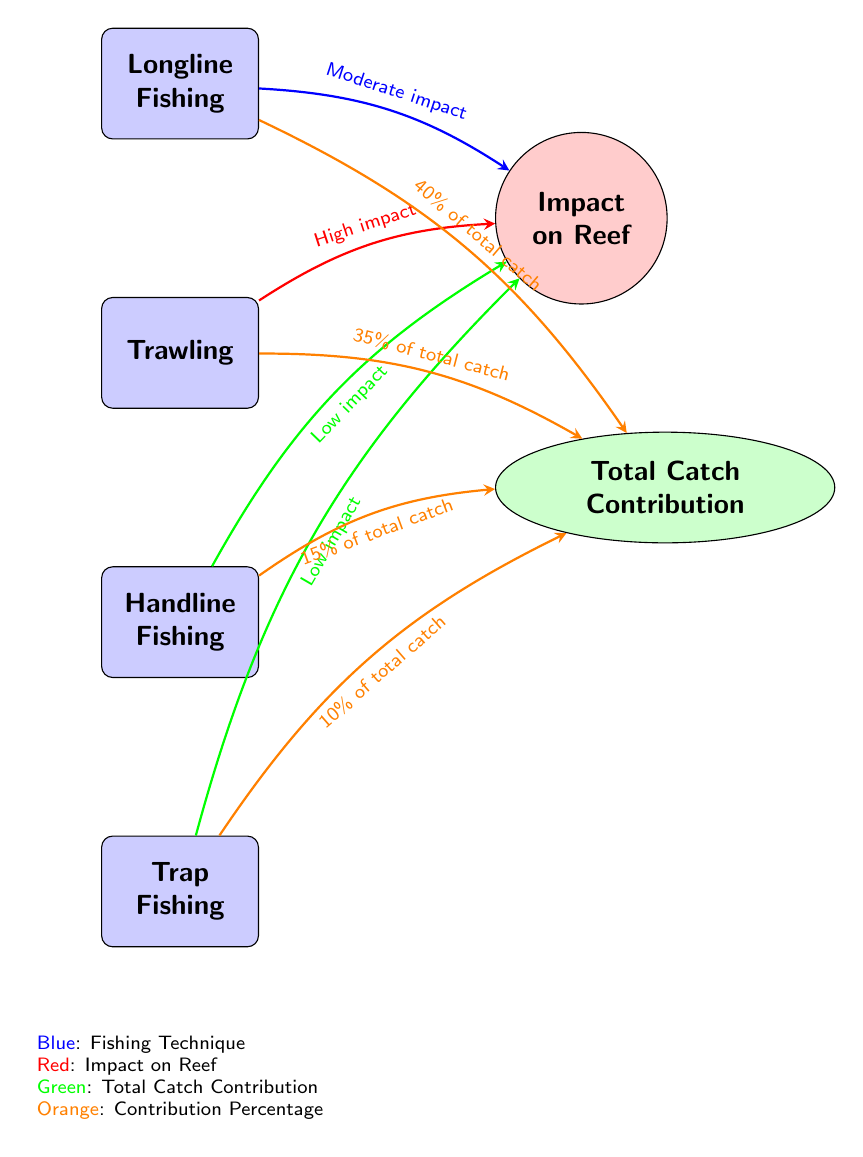What is the total catch contribution percentage for Longline Fishing? From the diagram, it's indicated that Longline Fishing contributes 40% of total catch, which is clearly labeled on the arrow pointing to the "Total Catch Contribution" node.
Answer: 40% What is the impact of Trawling on the reef? The diagram specifies that Trawling has a high impact on the reef, which is represented by the red arrow leading from the Trawling node to the "Impact on Reef" node.
Answer: High impact How many fishing techniques are represented in the diagram? By counting the nodes labeled as fishing techniques in the diagram, there are four techniques mentioned: Longline Fishing, Trawling, Handline Fishing, and Trap Fishing.
Answer: 4 What is the lowest contribution percentage of total catch in the diagram? The diagram shows that Trap Fishing contributes 10% of total catch, which is the lowest percentage among all fishing techniques represented in the diagram.
Answer: 10% If you combine the contributions of Handline Fishing and Trap Fishing, what is the total percentage? By adding the contributions of Handline Fishing (15%) and Trap Fishing (10%), the total contribution combining both techniques is 25%. This requires summing the two percentages shown in the diagram.
Answer: 25% Which fishing technique has a moderate impact on the reef? Longline Fishing is labeled in the diagram as having a moderate impact, as indicated by the blue arrow pointing towards the "Impact on Reef" node.
Answer: Longline Fishing What color represents the fishing techniques in the diagram? The fishing techniques are represented in blue, as indicated in the legend at the bottom of the diagram.
Answer: Blue Which fishing technique contributes the least to the total catch? The diagram indicates that Trap Fishing, which contributes 10% to the total catch, is the least contributing technique among those shown.
Answer: Trap Fishing How does the impact of Handline Fishing compare to Trap Fishing? The diagram states both techniques have low impact on the reef, thus indicating that their impacts are the same. This information is derived from observing the arrows leading from both techniques to the "Impact on Reef" node.
Answer: Low impact What percentage of total catch does Trawling contribute? Trawling contributes 35% to the total catch, as depicted in the diagram with the orange arrow pointing to the "Total Catch Contribution" node.
Answer: 35% 